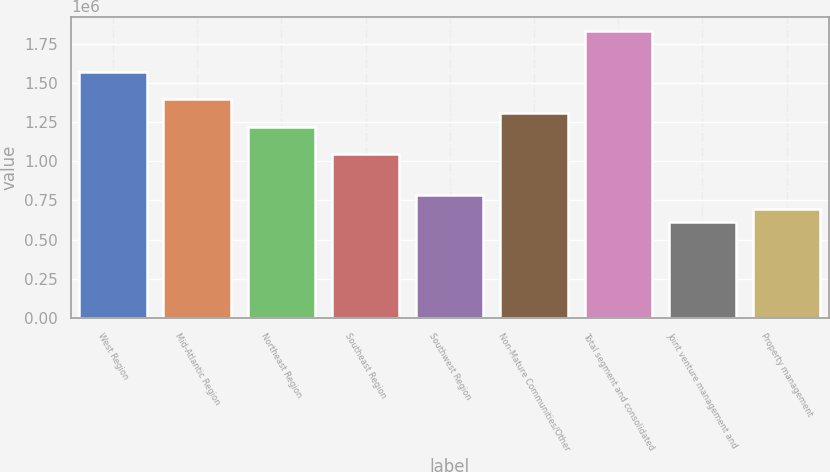Convert chart to OTSL. <chart><loc_0><loc_0><loc_500><loc_500><bar_chart><fcel>West Region<fcel>Mid-Atlantic Region<fcel>Northeast Region<fcel>Southeast Region<fcel>Southwest Region<fcel>Non-Mature Communities/Other<fcel>Total segment and consolidated<fcel>Joint venture management and<fcel>Property management<nl><fcel>1.56947e+06<fcel>1.39508e+06<fcel>1.2207e+06<fcel>1.04631e+06<fcel>784736<fcel>1.30789e+06<fcel>1.83105e+06<fcel>610350<fcel>697543<nl></chart> 